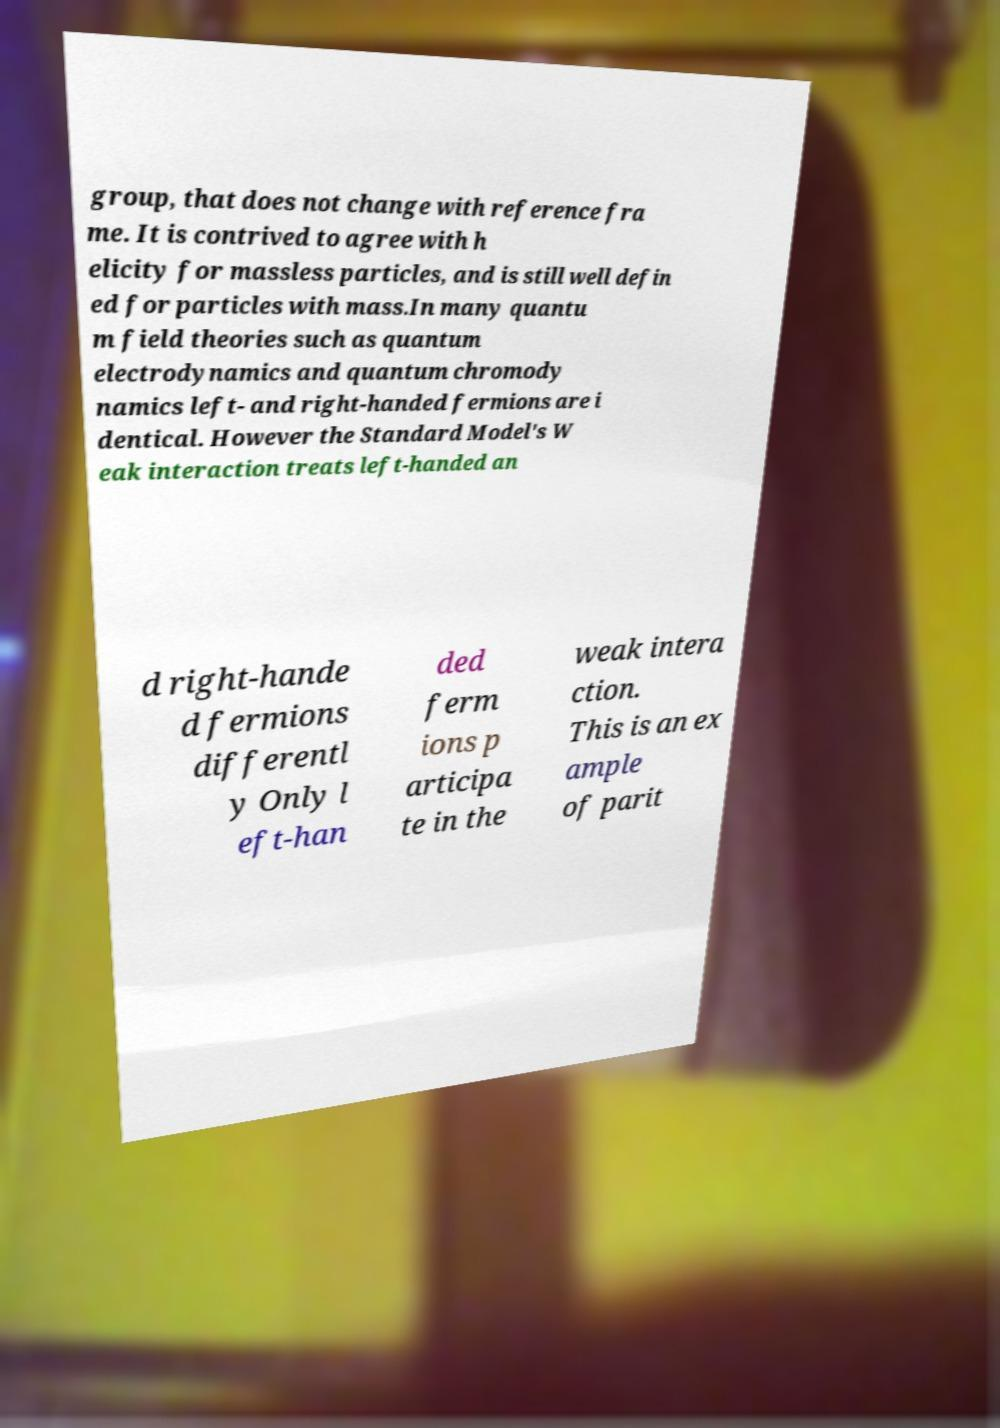Could you extract and type out the text from this image? group, that does not change with reference fra me. It is contrived to agree with h elicity for massless particles, and is still well defin ed for particles with mass.In many quantu m field theories such as quantum electrodynamics and quantum chromody namics left- and right-handed fermions are i dentical. However the Standard Model's W eak interaction treats left-handed an d right-hande d fermions differentl y Only l eft-han ded ferm ions p articipa te in the weak intera ction. This is an ex ample of parit 